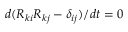Convert formula to latex. <formula><loc_0><loc_0><loc_500><loc_500>d ( R _ { k i } R _ { k j } - \delta _ { i j } ) / d t = 0</formula> 